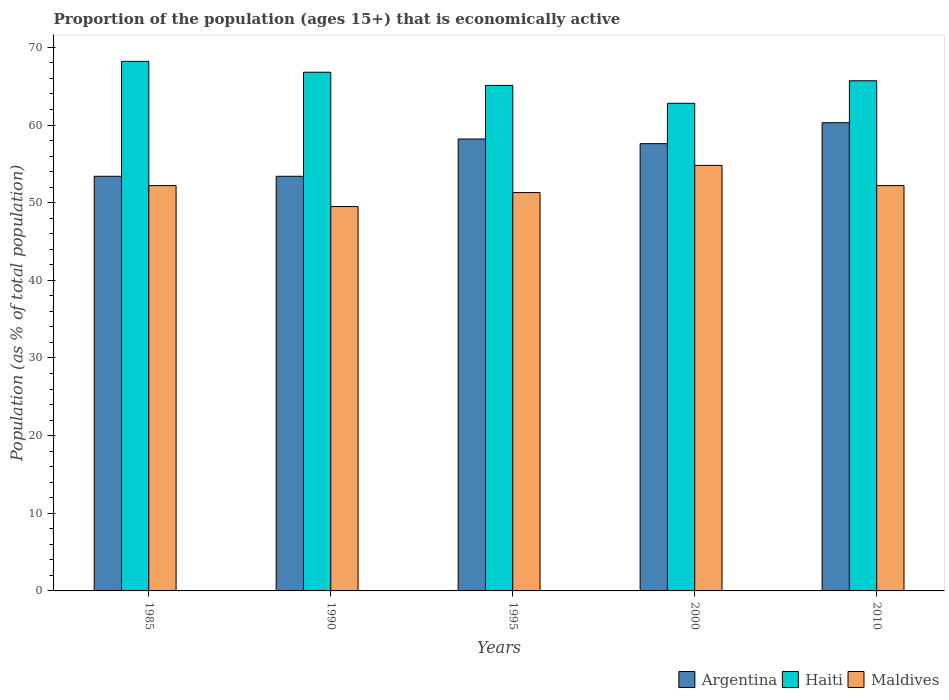How many groups of bars are there?
Your answer should be very brief. 5. Are the number of bars per tick equal to the number of legend labels?
Provide a succinct answer. Yes. How many bars are there on the 3rd tick from the right?
Provide a short and direct response. 3. In how many cases, is the number of bars for a given year not equal to the number of legend labels?
Your answer should be very brief. 0. What is the proportion of the population that is economically active in Maldives in 1995?
Provide a short and direct response. 51.3. Across all years, what is the maximum proportion of the population that is economically active in Maldives?
Give a very brief answer. 54.8. Across all years, what is the minimum proportion of the population that is economically active in Haiti?
Provide a succinct answer. 62.8. In which year was the proportion of the population that is economically active in Argentina maximum?
Offer a very short reply. 2010. In which year was the proportion of the population that is economically active in Haiti minimum?
Provide a short and direct response. 2000. What is the total proportion of the population that is economically active in Argentina in the graph?
Ensure brevity in your answer.  282.9. What is the difference between the proportion of the population that is economically active in Argentina in 1985 and that in 2000?
Provide a short and direct response. -4.2. What is the difference between the proportion of the population that is economically active in Argentina in 1985 and the proportion of the population that is economically active in Maldives in 1990?
Give a very brief answer. 3.9. What is the average proportion of the population that is economically active in Argentina per year?
Ensure brevity in your answer.  56.58. In the year 1985, what is the difference between the proportion of the population that is economically active in Maldives and proportion of the population that is economically active in Argentina?
Your answer should be very brief. -1.2. What is the ratio of the proportion of the population that is economically active in Maldives in 2000 to that in 2010?
Provide a short and direct response. 1.05. Is the difference between the proportion of the population that is economically active in Maldives in 1995 and 2000 greater than the difference between the proportion of the population that is economically active in Argentina in 1995 and 2000?
Keep it short and to the point. No. What is the difference between the highest and the second highest proportion of the population that is economically active in Haiti?
Provide a succinct answer. 1.4. What is the difference between the highest and the lowest proportion of the population that is economically active in Argentina?
Offer a very short reply. 6.9. In how many years, is the proportion of the population that is economically active in Maldives greater than the average proportion of the population that is economically active in Maldives taken over all years?
Keep it short and to the point. 3. What does the 2nd bar from the left in 2000 represents?
Provide a short and direct response. Haiti. What does the 1st bar from the right in 1985 represents?
Your response must be concise. Maldives. Are the values on the major ticks of Y-axis written in scientific E-notation?
Your answer should be very brief. No. Does the graph contain any zero values?
Make the answer very short. No. How are the legend labels stacked?
Provide a succinct answer. Horizontal. What is the title of the graph?
Keep it short and to the point. Proportion of the population (ages 15+) that is economically active. What is the label or title of the X-axis?
Provide a short and direct response. Years. What is the label or title of the Y-axis?
Give a very brief answer. Population (as % of total population). What is the Population (as % of total population) in Argentina in 1985?
Provide a succinct answer. 53.4. What is the Population (as % of total population) in Haiti in 1985?
Your answer should be very brief. 68.2. What is the Population (as % of total population) in Maldives in 1985?
Ensure brevity in your answer.  52.2. What is the Population (as % of total population) of Argentina in 1990?
Provide a succinct answer. 53.4. What is the Population (as % of total population) of Haiti in 1990?
Your response must be concise. 66.8. What is the Population (as % of total population) of Maldives in 1990?
Your response must be concise. 49.5. What is the Population (as % of total population) of Argentina in 1995?
Your response must be concise. 58.2. What is the Population (as % of total population) of Haiti in 1995?
Provide a short and direct response. 65.1. What is the Population (as % of total population) in Maldives in 1995?
Provide a succinct answer. 51.3. What is the Population (as % of total population) in Argentina in 2000?
Your response must be concise. 57.6. What is the Population (as % of total population) of Haiti in 2000?
Ensure brevity in your answer.  62.8. What is the Population (as % of total population) in Maldives in 2000?
Your answer should be compact. 54.8. What is the Population (as % of total population) in Argentina in 2010?
Offer a very short reply. 60.3. What is the Population (as % of total population) in Haiti in 2010?
Keep it short and to the point. 65.7. What is the Population (as % of total population) in Maldives in 2010?
Your response must be concise. 52.2. Across all years, what is the maximum Population (as % of total population) of Argentina?
Offer a very short reply. 60.3. Across all years, what is the maximum Population (as % of total population) in Haiti?
Offer a very short reply. 68.2. Across all years, what is the maximum Population (as % of total population) of Maldives?
Ensure brevity in your answer.  54.8. Across all years, what is the minimum Population (as % of total population) of Argentina?
Offer a very short reply. 53.4. Across all years, what is the minimum Population (as % of total population) of Haiti?
Your response must be concise. 62.8. Across all years, what is the minimum Population (as % of total population) of Maldives?
Your answer should be compact. 49.5. What is the total Population (as % of total population) in Argentina in the graph?
Keep it short and to the point. 282.9. What is the total Population (as % of total population) in Haiti in the graph?
Offer a terse response. 328.6. What is the total Population (as % of total population) of Maldives in the graph?
Your answer should be compact. 260. What is the difference between the Population (as % of total population) in Argentina in 1985 and that in 1990?
Ensure brevity in your answer.  0. What is the difference between the Population (as % of total population) in Haiti in 1985 and that in 1990?
Your answer should be compact. 1.4. What is the difference between the Population (as % of total population) in Maldives in 1985 and that in 1990?
Make the answer very short. 2.7. What is the difference between the Population (as % of total population) of Argentina in 1985 and that in 1995?
Your answer should be very brief. -4.8. What is the difference between the Population (as % of total population) of Haiti in 1985 and that in 1995?
Give a very brief answer. 3.1. What is the difference between the Population (as % of total population) of Maldives in 1985 and that in 1995?
Your response must be concise. 0.9. What is the difference between the Population (as % of total population) of Argentina in 1985 and that in 2000?
Your response must be concise. -4.2. What is the difference between the Population (as % of total population) of Maldives in 1985 and that in 2000?
Give a very brief answer. -2.6. What is the difference between the Population (as % of total population) of Argentina in 1985 and that in 2010?
Offer a very short reply. -6.9. What is the difference between the Population (as % of total population) in Maldives in 1985 and that in 2010?
Provide a short and direct response. 0. What is the difference between the Population (as % of total population) in Argentina in 1990 and that in 1995?
Give a very brief answer. -4.8. What is the difference between the Population (as % of total population) in Maldives in 1990 and that in 1995?
Your answer should be very brief. -1.8. What is the difference between the Population (as % of total population) of Maldives in 1990 and that in 2010?
Your answer should be very brief. -2.7. What is the difference between the Population (as % of total population) of Argentina in 1995 and that in 2000?
Provide a short and direct response. 0.6. What is the difference between the Population (as % of total population) in Haiti in 1995 and that in 2010?
Your response must be concise. -0.6. What is the difference between the Population (as % of total population) of Maldives in 1995 and that in 2010?
Make the answer very short. -0.9. What is the difference between the Population (as % of total population) in Argentina in 2000 and that in 2010?
Your response must be concise. -2.7. What is the difference between the Population (as % of total population) of Haiti in 2000 and that in 2010?
Keep it short and to the point. -2.9. What is the difference between the Population (as % of total population) in Maldives in 2000 and that in 2010?
Your response must be concise. 2.6. What is the difference between the Population (as % of total population) in Haiti in 1985 and the Population (as % of total population) in Maldives in 1990?
Your answer should be very brief. 18.7. What is the difference between the Population (as % of total population) of Argentina in 1985 and the Population (as % of total population) of Haiti in 2000?
Make the answer very short. -9.4. What is the difference between the Population (as % of total population) in Argentina in 1985 and the Population (as % of total population) in Maldives in 2000?
Make the answer very short. -1.4. What is the difference between the Population (as % of total population) of Haiti in 1985 and the Population (as % of total population) of Maldives in 2010?
Your answer should be very brief. 16. What is the difference between the Population (as % of total population) in Argentina in 1990 and the Population (as % of total population) in Haiti in 1995?
Provide a succinct answer. -11.7. What is the difference between the Population (as % of total population) of Argentina in 1990 and the Population (as % of total population) of Maldives in 1995?
Offer a very short reply. 2.1. What is the difference between the Population (as % of total population) in Argentina in 1990 and the Population (as % of total population) in Haiti in 2010?
Provide a succinct answer. -12.3. What is the difference between the Population (as % of total population) of Argentina in 1990 and the Population (as % of total population) of Maldives in 2010?
Make the answer very short. 1.2. What is the difference between the Population (as % of total population) of Haiti in 1990 and the Population (as % of total population) of Maldives in 2010?
Ensure brevity in your answer.  14.6. What is the difference between the Population (as % of total population) in Argentina in 1995 and the Population (as % of total population) in Haiti in 2000?
Make the answer very short. -4.6. What is the difference between the Population (as % of total population) in Argentina in 2000 and the Population (as % of total population) in Maldives in 2010?
Your answer should be very brief. 5.4. What is the difference between the Population (as % of total population) of Haiti in 2000 and the Population (as % of total population) of Maldives in 2010?
Provide a short and direct response. 10.6. What is the average Population (as % of total population) of Argentina per year?
Offer a very short reply. 56.58. What is the average Population (as % of total population) in Haiti per year?
Provide a short and direct response. 65.72. What is the average Population (as % of total population) in Maldives per year?
Offer a very short reply. 52. In the year 1985, what is the difference between the Population (as % of total population) of Argentina and Population (as % of total population) of Haiti?
Keep it short and to the point. -14.8. In the year 1985, what is the difference between the Population (as % of total population) of Argentina and Population (as % of total population) of Maldives?
Offer a terse response. 1.2. In the year 2000, what is the difference between the Population (as % of total population) of Argentina and Population (as % of total population) of Haiti?
Your response must be concise. -5.2. In the year 2010, what is the difference between the Population (as % of total population) in Argentina and Population (as % of total population) in Haiti?
Your answer should be very brief. -5.4. In the year 2010, what is the difference between the Population (as % of total population) of Argentina and Population (as % of total population) of Maldives?
Keep it short and to the point. 8.1. In the year 2010, what is the difference between the Population (as % of total population) of Haiti and Population (as % of total population) of Maldives?
Your answer should be compact. 13.5. What is the ratio of the Population (as % of total population) of Haiti in 1985 to that in 1990?
Provide a succinct answer. 1.02. What is the ratio of the Population (as % of total population) of Maldives in 1985 to that in 1990?
Offer a very short reply. 1.05. What is the ratio of the Population (as % of total population) of Argentina in 1985 to that in 1995?
Your answer should be very brief. 0.92. What is the ratio of the Population (as % of total population) in Haiti in 1985 to that in 1995?
Your answer should be compact. 1.05. What is the ratio of the Population (as % of total population) of Maldives in 1985 to that in 1995?
Provide a succinct answer. 1.02. What is the ratio of the Population (as % of total population) of Argentina in 1985 to that in 2000?
Make the answer very short. 0.93. What is the ratio of the Population (as % of total population) of Haiti in 1985 to that in 2000?
Offer a very short reply. 1.09. What is the ratio of the Population (as % of total population) of Maldives in 1985 to that in 2000?
Provide a short and direct response. 0.95. What is the ratio of the Population (as % of total population) of Argentina in 1985 to that in 2010?
Keep it short and to the point. 0.89. What is the ratio of the Population (as % of total population) of Haiti in 1985 to that in 2010?
Give a very brief answer. 1.04. What is the ratio of the Population (as % of total population) in Argentina in 1990 to that in 1995?
Your answer should be very brief. 0.92. What is the ratio of the Population (as % of total population) of Haiti in 1990 to that in 1995?
Your answer should be very brief. 1.03. What is the ratio of the Population (as % of total population) of Maldives in 1990 to that in 1995?
Provide a short and direct response. 0.96. What is the ratio of the Population (as % of total population) of Argentina in 1990 to that in 2000?
Provide a short and direct response. 0.93. What is the ratio of the Population (as % of total population) of Haiti in 1990 to that in 2000?
Offer a terse response. 1.06. What is the ratio of the Population (as % of total population) of Maldives in 1990 to that in 2000?
Offer a terse response. 0.9. What is the ratio of the Population (as % of total population) of Argentina in 1990 to that in 2010?
Your answer should be very brief. 0.89. What is the ratio of the Population (as % of total population) in Haiti in 1990 to that in 2010?
Your answer should be compact. 1.02. What is the ratio of the Population (as % of total population) in Maldives in 1990 to that in 2010?
Your response must be concise. 0.95. What is the ratio of the Population (as % of total population) in Argentina in 1995 to that in 2000?
Give a very brief answer. 1.01. What is the ratio of the Population (as % of total population) of Haiti in 1995 to that in 2000?
Your answer should be compact. 1.04. What is the ratio of the Population (as % of total population) of Maldives in 1995 to that in 2000?
Provide a short and direct response. 0.94. What is the ratio of the Population (as % of total population) of Argentina in 1995 to that in 2010?
Provide a succinct answer. 0.97. What is the ratio of the Population (as % of total population) in Haiti in 1995 to that in 2010?
Your answer should be very brief. 0.99. What is the ratio of the Population (as % of total population) in Maldives in 1995 to that in 2010?
Provide a succinct answer. 0.98. What is the ratio of the Population (as % of total population) of Argentina in 2000 to that in 2010?
Make the answer very short. 0.96. What is the ratio of the Population (as % of total population) in Haiti in 2000 to that in 2010?
Offer a very short reply. 0.96. What is the ratio of the Population (as % of total population) in Maldives in 2000 to that in 2010?
Give a very brief answer. 1.05. What is the difference between the highest and the second highest Population (as % of total population) of Argentina?
Provide a short and direct response. 2.1. What is the difference between the highest and the second highest Population (as % of total population) in Haiti?
Your answer should be compact. 1.4. What is the difference between the highest and the second highest Population (as % of total population) in Maldives?
Offer a very short reply. 2.6. What is the difference between the highest and the lowest Population (as % of total population) of Argentina?
Offer a very short reply. 6.9. What is the difference between the highest and the lowest Population (as % of total population) in Haiti?
Make the answer very short. 5.4. 